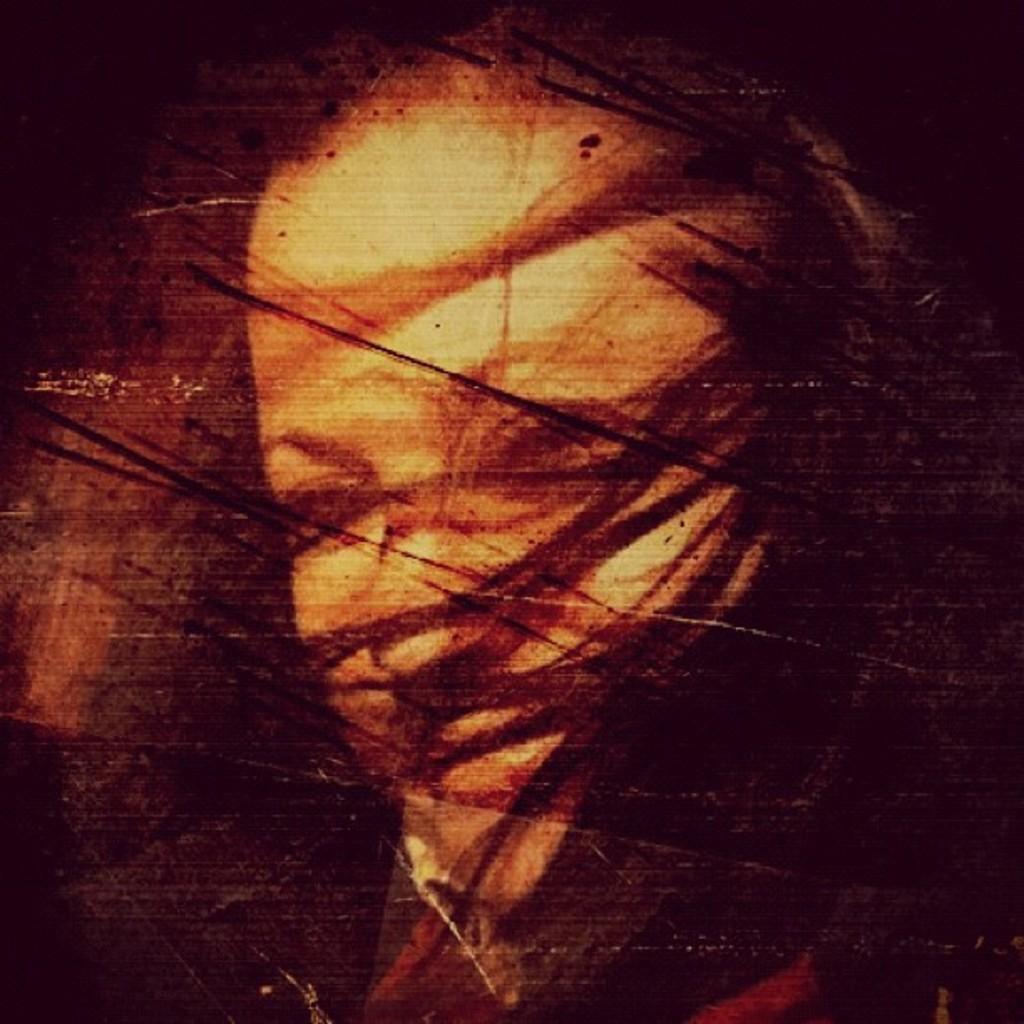Describe this image in one or two sentences. In this picture we can see painting of a person's face on the wall. 